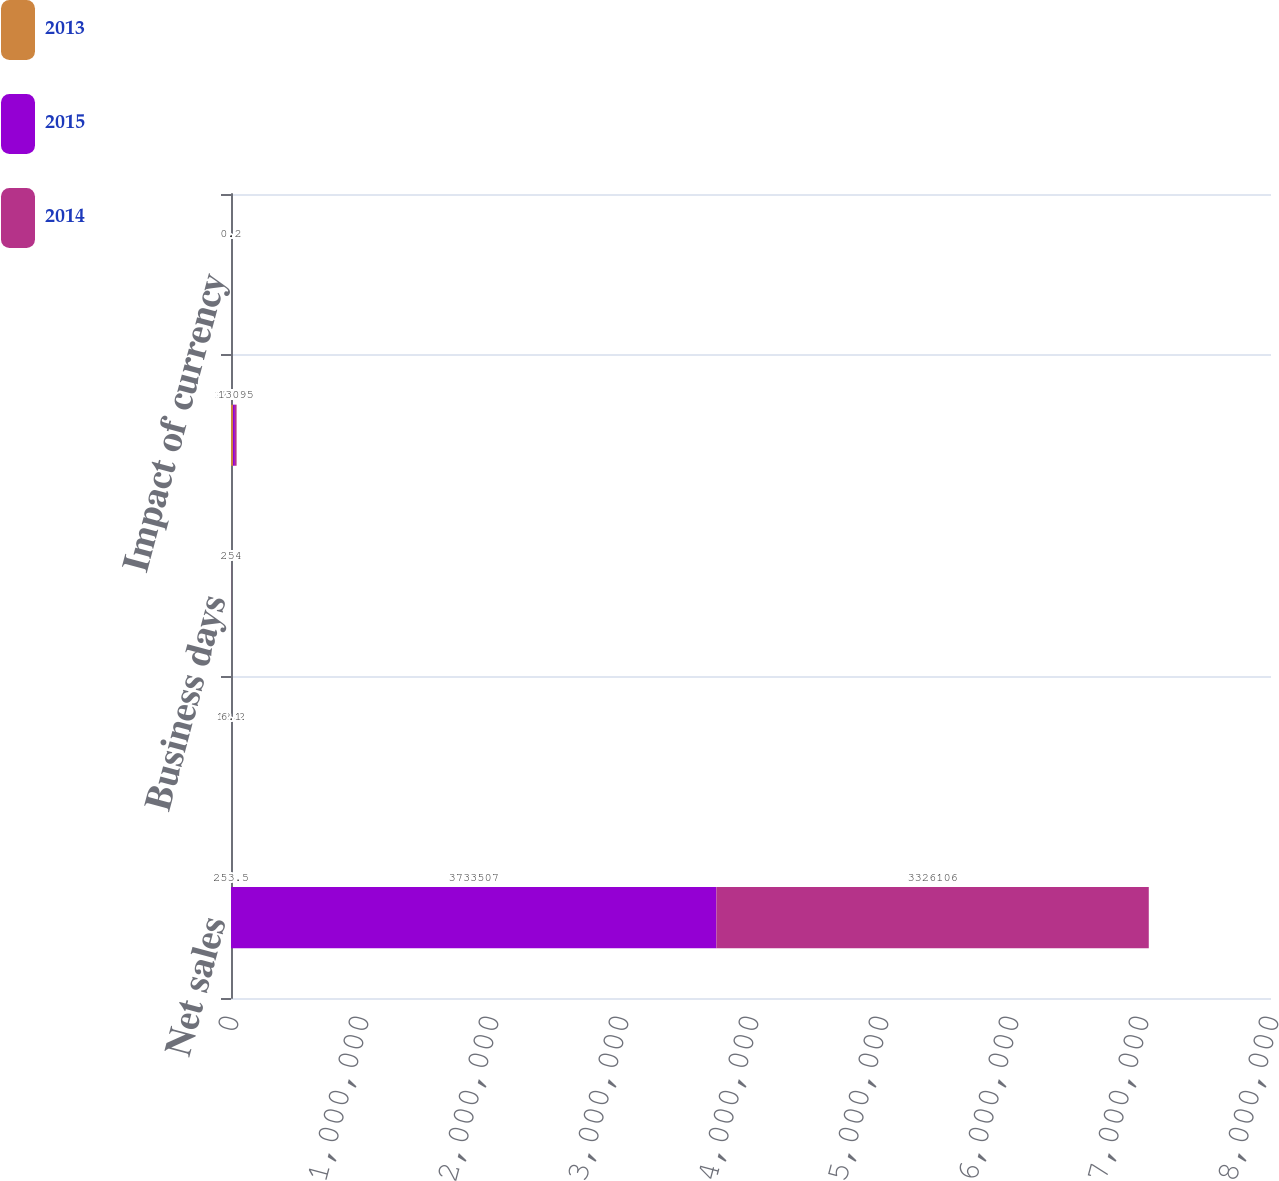<chart> <loc_0><loc_0><loc_500><loc_500><stacked_bar_chart><ecel><fcel>Net sales<fcel>Percentage change<fcel>Business days<fcel>Daily sales<fcel>Impact of currency<nl><fcel>2013<fcel>253.5<fcel>3.6<fcel>254<fcel>15233<fcel>1.2<nl><fcel>2015<fcel>3.73351e+06<fcel>12.2<fcel>253<fcel>14757<fcel>0.5<nl><fcel>2014<fcel>3.32611e+06<fcel>6.1<fcel>254<fcel>13095<fcel>0.2<nl></chart> 